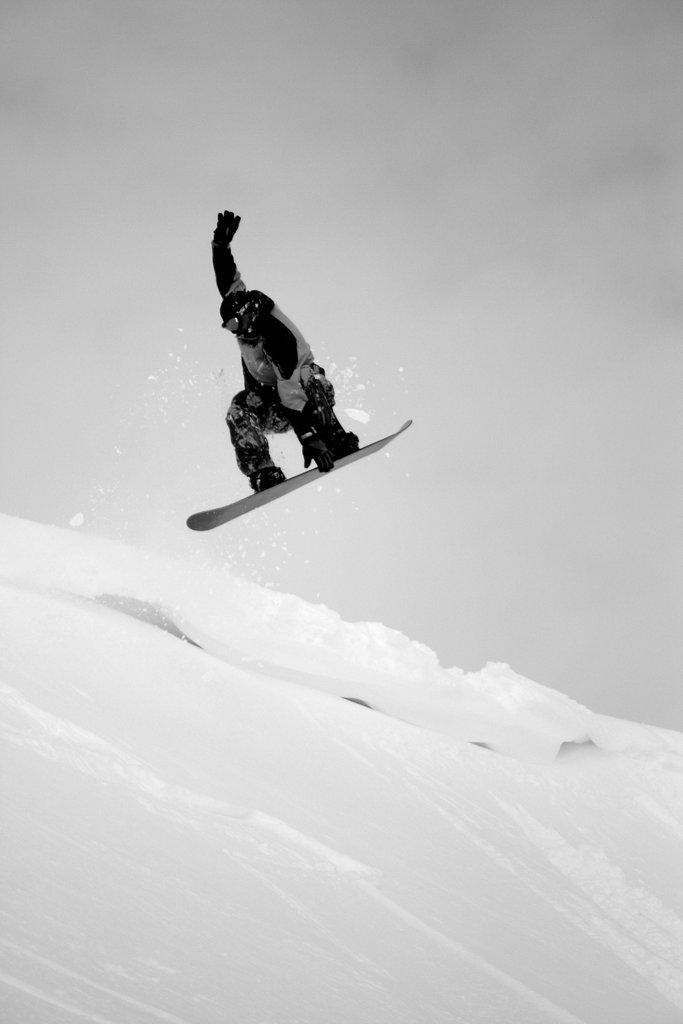What is the person in the image doing? The person is surfing on the snow. What is the person wearing while surfing? The person is wearing a different costume. What can be seen in the background of the image? There is sky and snow visible in the background of the image. What is the condition of the sky in the image? The sky has clouds in it. What type of horn can be seen on the plantation in the image? There is no horn or plantation present in the image. What does the person's mom think about their snow surfing skills in the image? There is no information about the person's mom or their opinion in the image. 